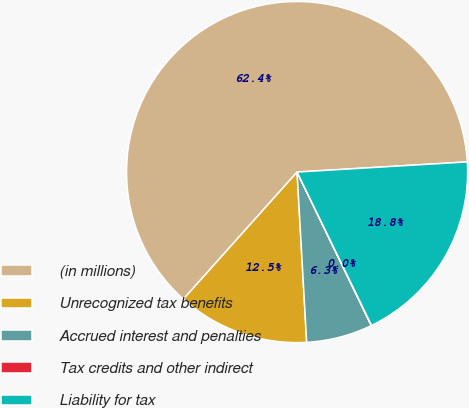Convert chart to OTSL. <chart><loc_0><loc_0><loc_500><loc_500><pie_chart><fcel>(in millions)<fcel>Unrecognized tax benefits<fcel>Accrued interest and penalties<fcel>Tax credits and other indirect<fcel>Liability for tax<nl><fcel>62.43%<fcel>12.51%<fcel>6.27%<fcel>0.03%<fcel>18.75%<nl></chart> 